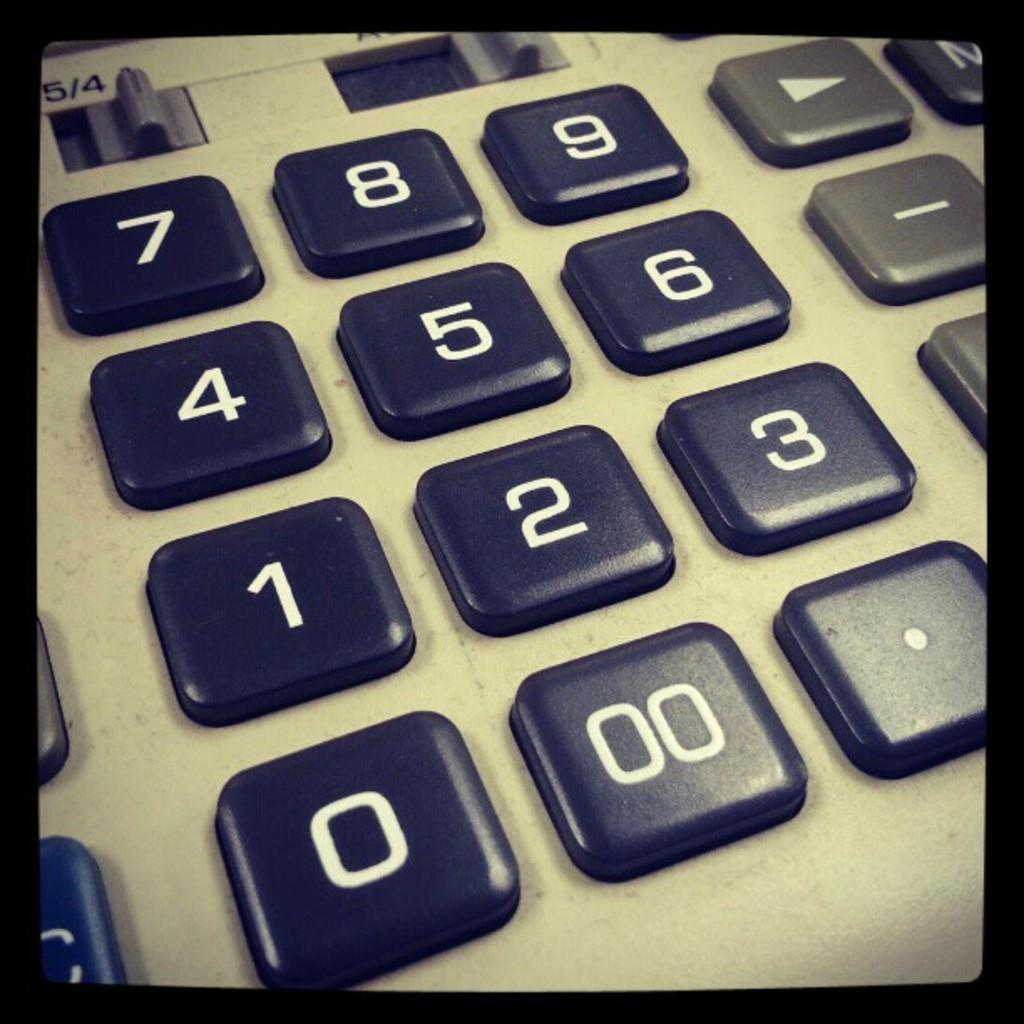<image>
Share a concise interpretation of the image provided. a close up of calculator keys like 00 and 9 